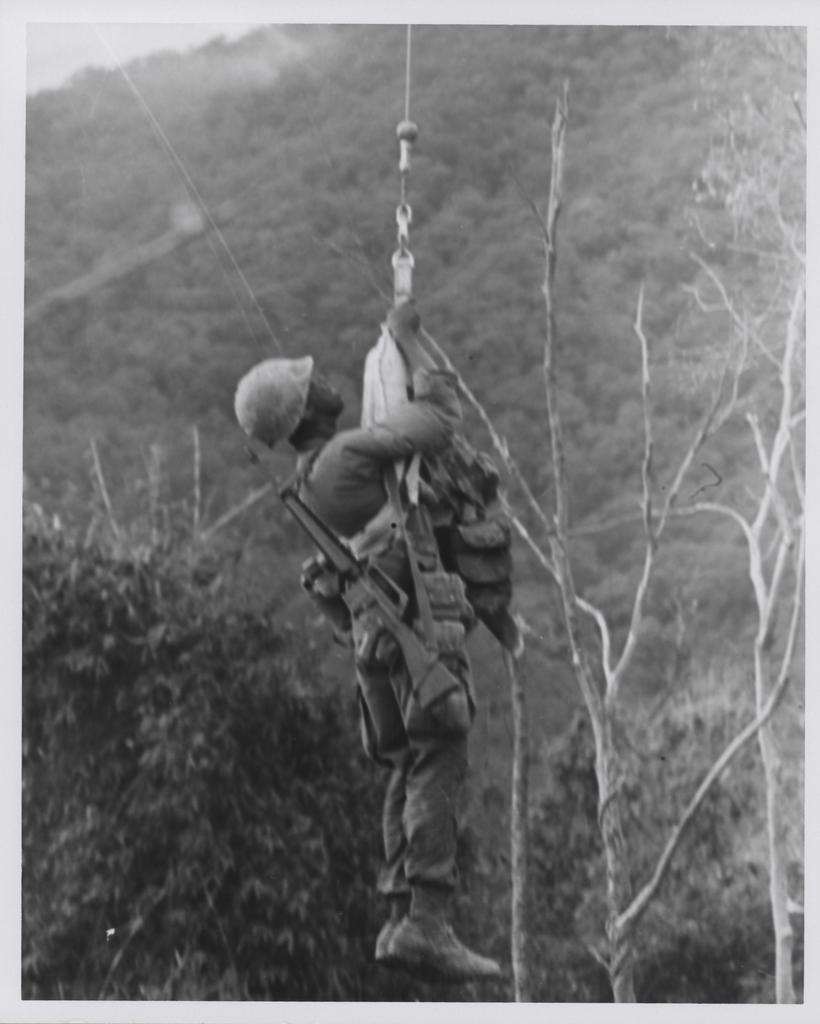How would you summarize this image in a sentence or two? In this image there is an army personnel hanging from the rope, around the person there are trees and mountains. 